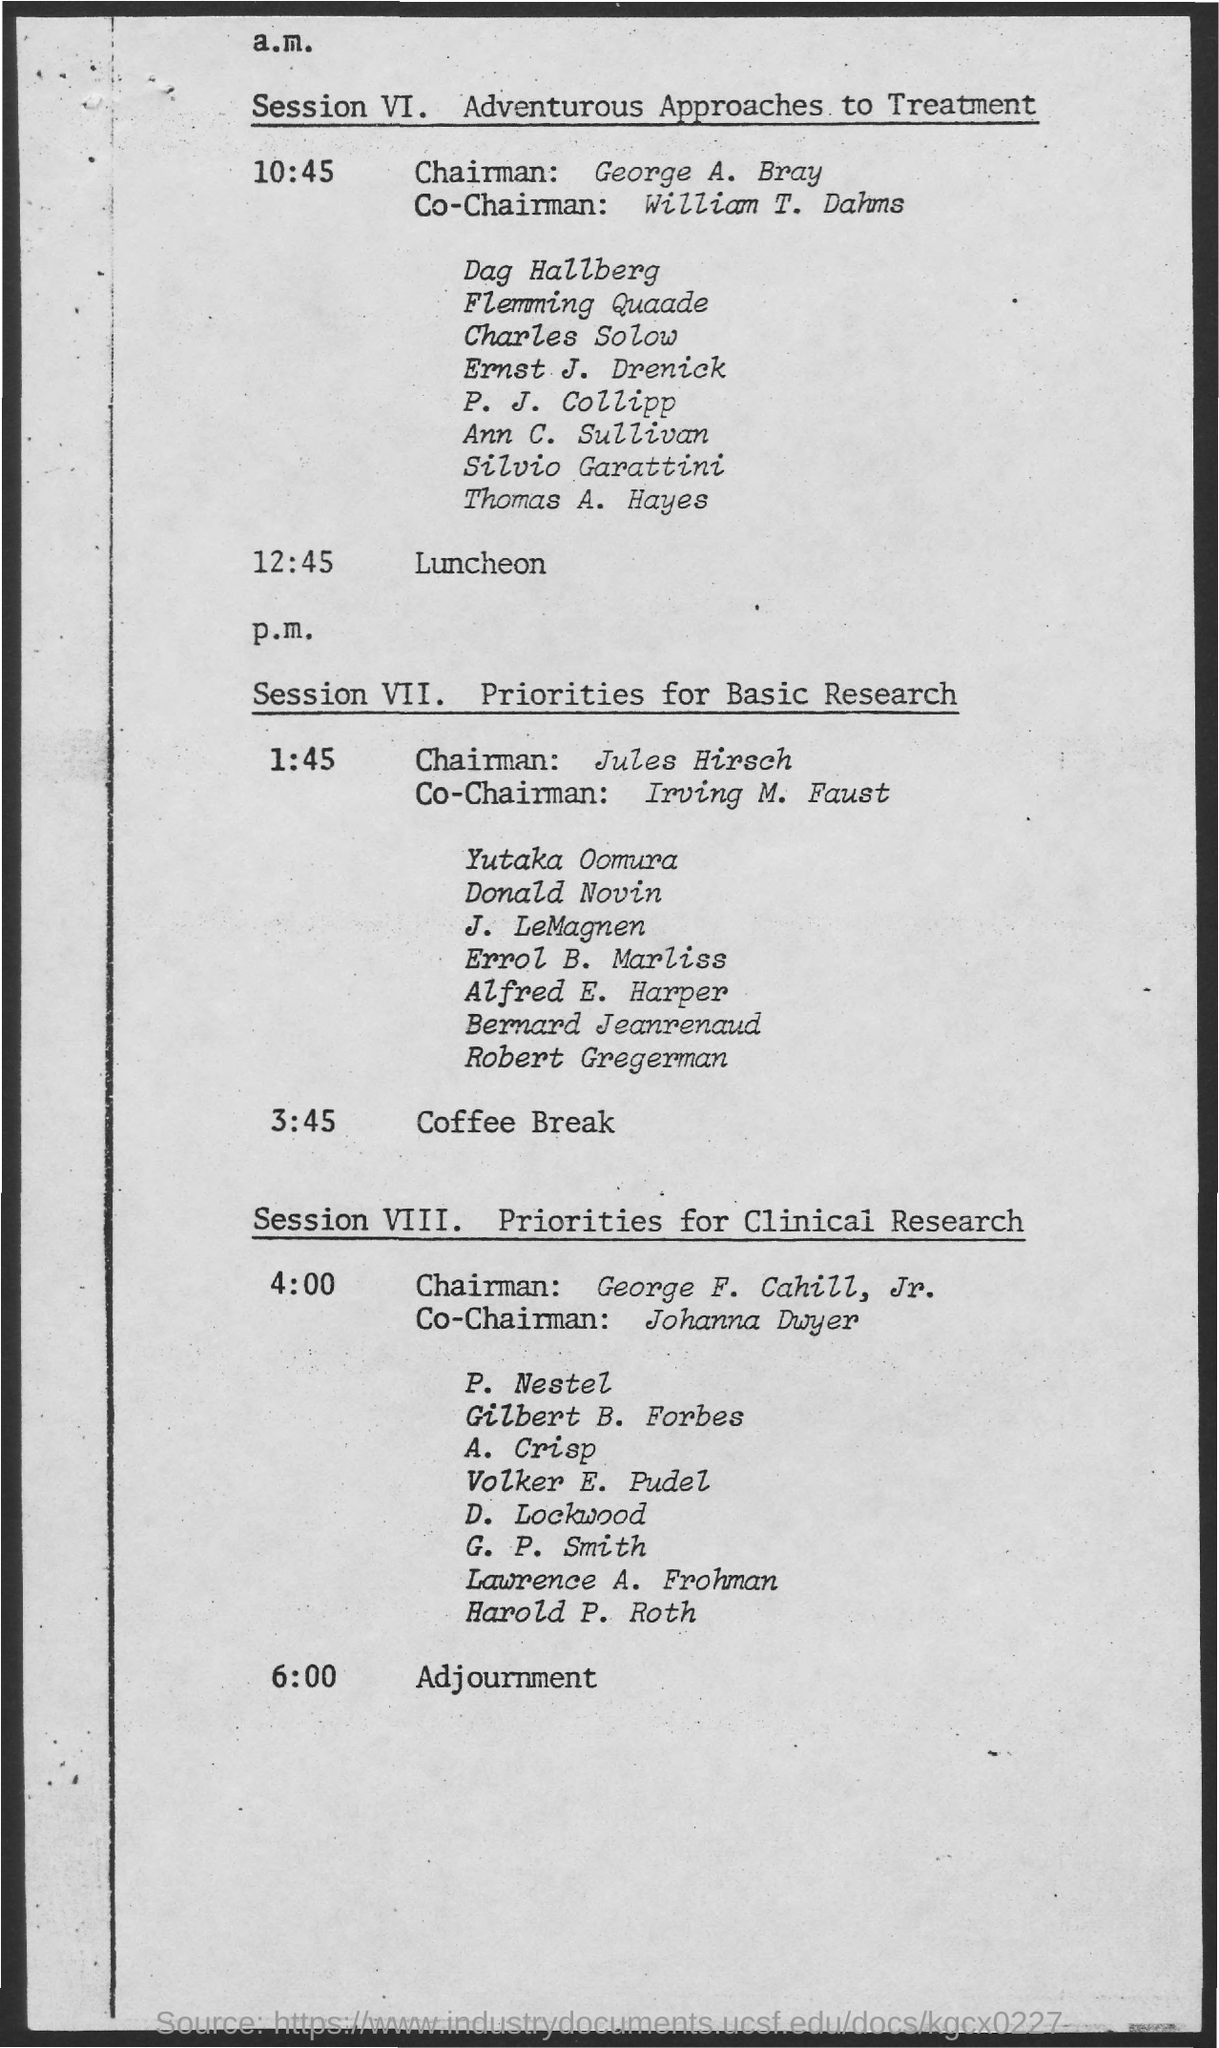What is session vi about?
Offer a very short reply. Adventurous Approaches to Treatment. What is session vii about?
Ensure brevity in your answer.  Priorities for Basic Research. What is session viii about?
Make the answer very short. Priorities for Clinical Research. Who is the chairman for session vi?
Offer a terse response. George A. Bray. Who is the co- chairman for session vi?
Your answer should be very brief. William T. Dahms. Who is the chairman for session vii
Keep it short and to the point. Jules Hirsch. Who is the co-chairman for session vii?
Provide a succinct answer. Irving M. Faust. Who is the chairman for Session VIII?
Offer a terse response. George F. Cahill, Jr. Who is the co- chairman for session viii?
Make the answer very short. Johanna Dwyer. 